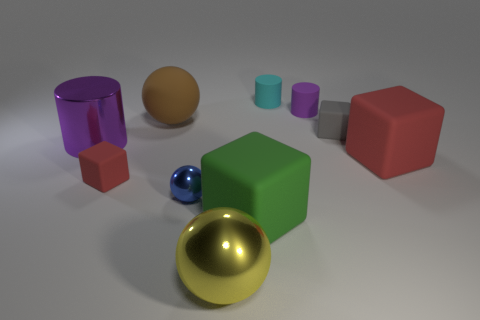What size is the cylinder that is the same material as the blue object?
Make the answer very short. Large. There is a small sphere; are there any purple cylinders in front of it?
Offer a terse response. No. Do the blue object and the gray thing have the same shape?
Offer a very short reply. No. How big is the purple cylinder that is behind the purple cylinder that is to the left of the red matte block to the left of the gray block?
Offer a very short reply. Small. What material is the large brown sphere?
Ensure brevity in your answer.  Rubber. The other rubber cylinder that is the same color as the big cylinder is what size?
Offer a terse response. Small. Is the shape of the small cyan object the same as the purple thing right of the cyan matte cylinder?
Ensure brevity in your answer.  Yes. What is the material of the red cube that is to the right of the tiny rubber cube that is right of the small cylinder in front of the tiny cyan rubber cylinder?
Offer a very short reply. Rubber. What number of small cyan matte cylinders are there?
Provide a short and direct response. 1. What number of cyan objects are either large things or matte cylinders?
Keep it short and to the point. 1. 